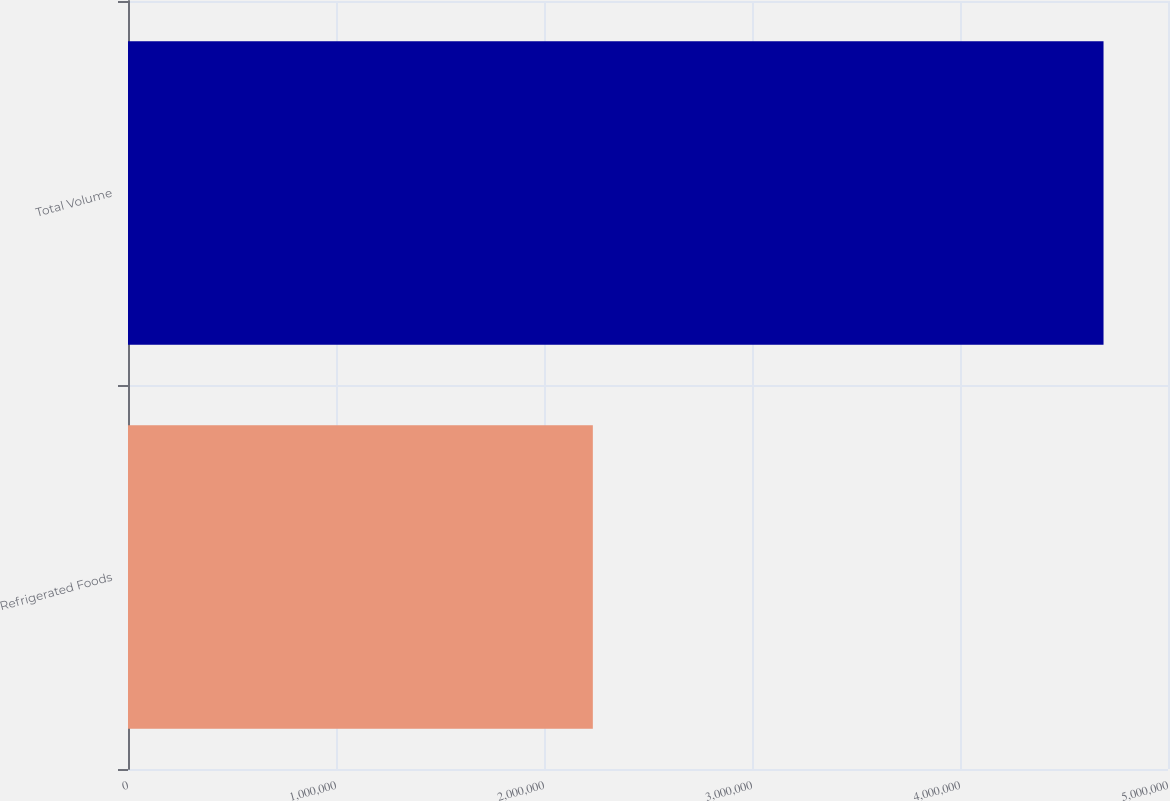<chart> <loc_0><loc_0><loc_500><loc_500><bar_chart><fcel>Refrigerated Foods<fcel>Total Volume<nl><fcel>2.2348e+06<fcel>4.69003e+06<nl></chart> 